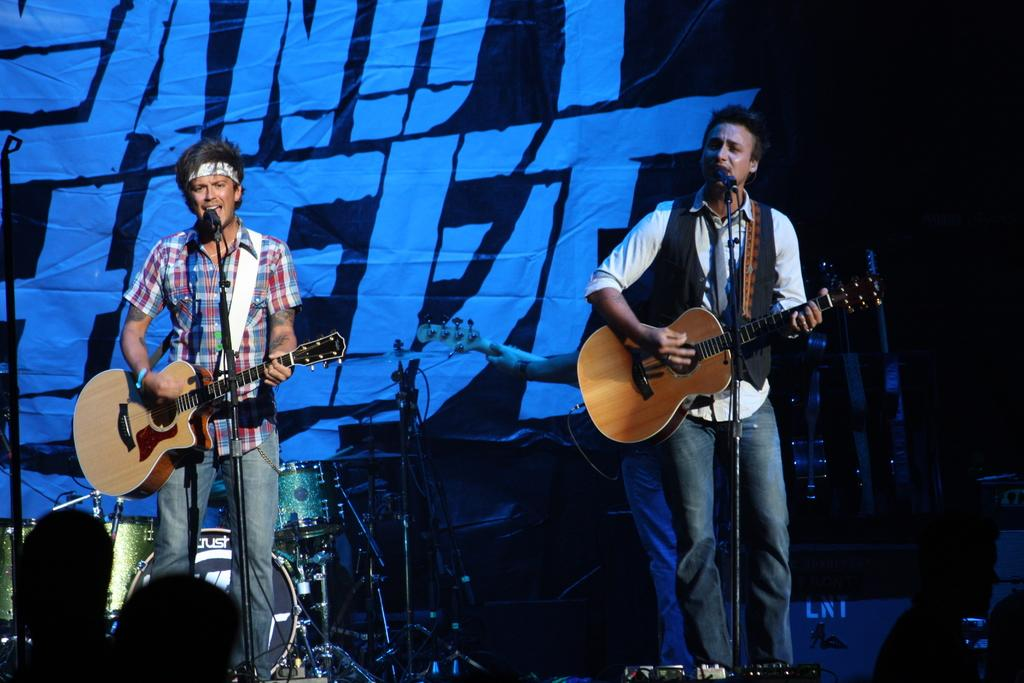How many people are in the image? There are two persons in the image. What are the two persons doing in the image? The two persons are singing on a microphone and playing guitars. What other objects related to music can be seen in the image? There are musical instruments in the image. What is visible in the background of the image? There is a banner in the background of the image. What type of flower is being served as a meal in the image? There is no flower or meal present in the image; it features two persons singing and playing guitars with musical instruments and a banner in the background. Can you tell me how many rats are visible in the image? There are no rats present in the image. 